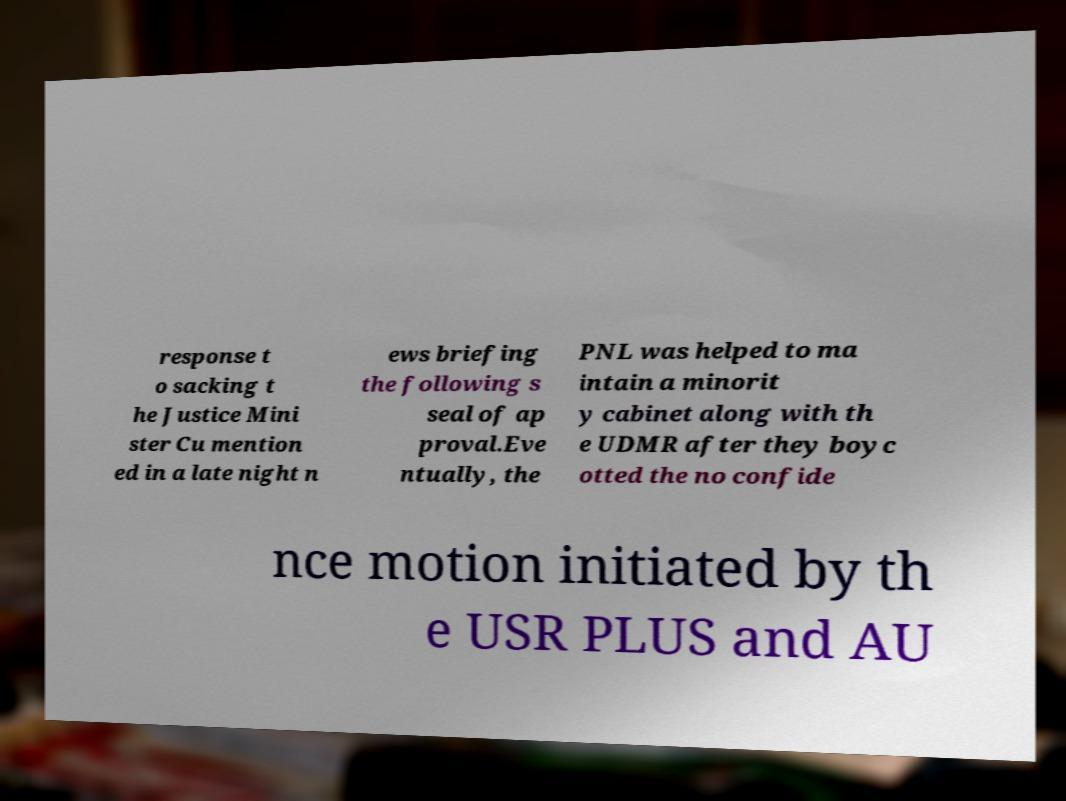Can you read and provide the text displayed in the image?This photo seems to have some interesting text. Can you extract and type it out for me? response t o sacking t he Justice Mini ster Cu mention ed in a late night n ews briefing the following s seal of ap proval.Eve ntually, the PNL was helped to ma intain a minorit y cabinet along with th e UDMR after they boyc otted the no confide nce motion initiated by th e USR PLUS and AU 